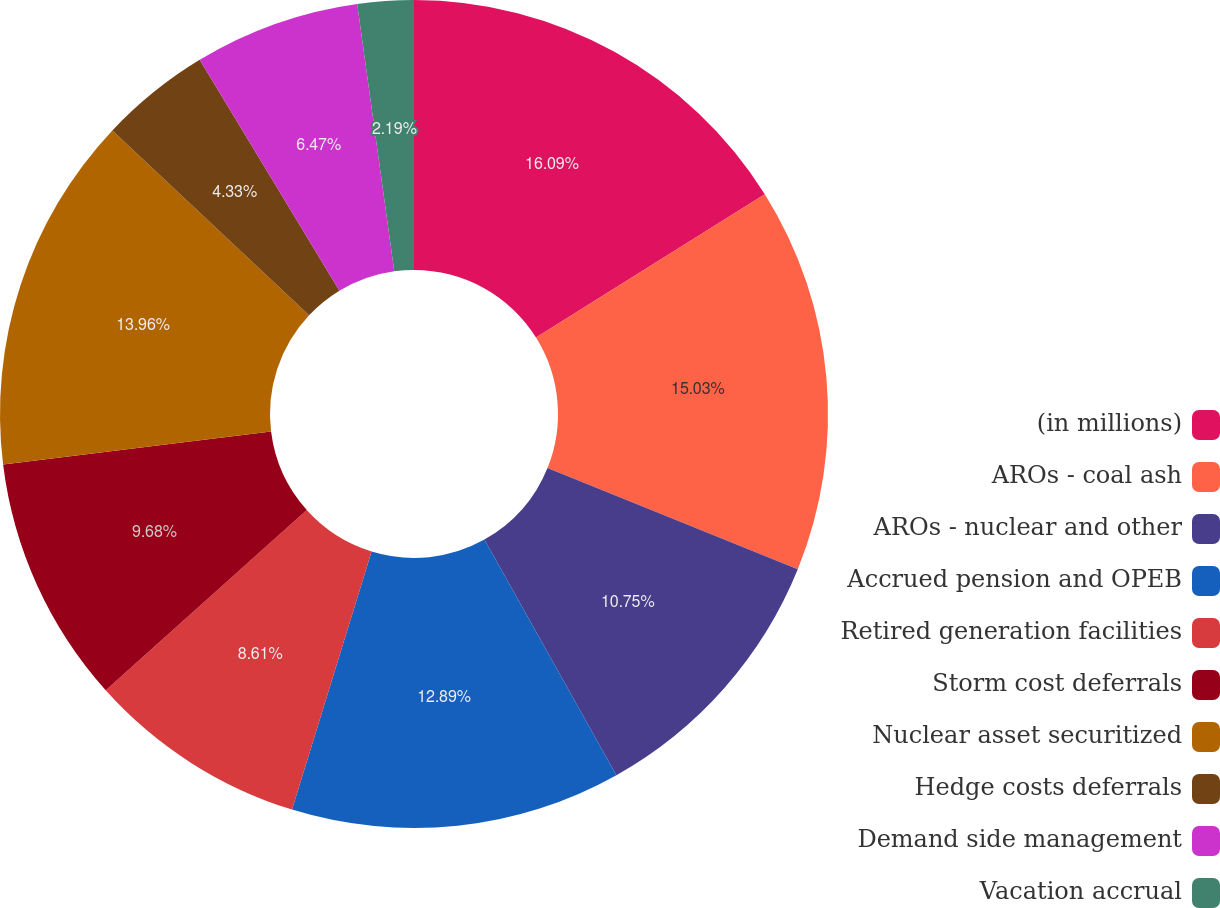<chart> <loc_0><loc_0><loc_500><loc_500><pie_chart><fcel>(in millions)<fcel>AROs - coal ash<fcel>AROs - nuclear and other<fcel>Accrued pension and OPEB<fcel>Retired generation facilities<fcel>Storm cost deferrals<fcel>Nuclear asset securitized<fcel>Hedge costs deferrals<fcel>Demand side management<fcel>Vacation accrual<nl><fcel>16.09%<fcel>15.03%<fcel>10.75%<fcel>12.89%<fcel>8.61%<fcel>9.68%<fcel>13.96%<fcel>4.33%<fcel>6.47%<fcel>2.19%<nl></chart> 